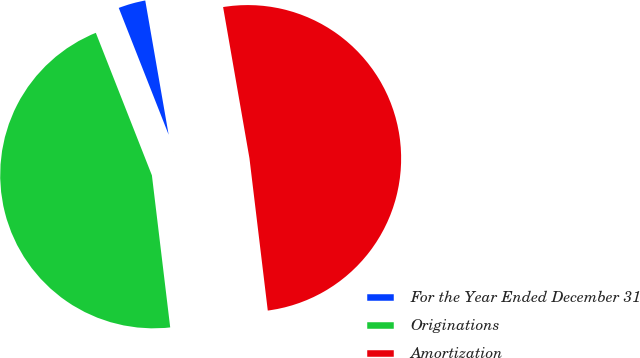<chart> <loc_0><loc_0><loc_500><loc_500><pie_chart><fcel>For the Year Ended December 31<fcel>Originations<fcel>Amortization<nl><fcel>3.22%<fcel>45.94%<fcel>50.84%<nl></chart> 